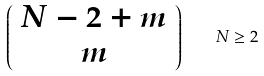<formula> <loc_0><loc_0><loc_500><loc_500>\left ( \begin{array} { c } N - 2 + m \\ m \end{array} \right ) \quad N \geq 2</formula> 